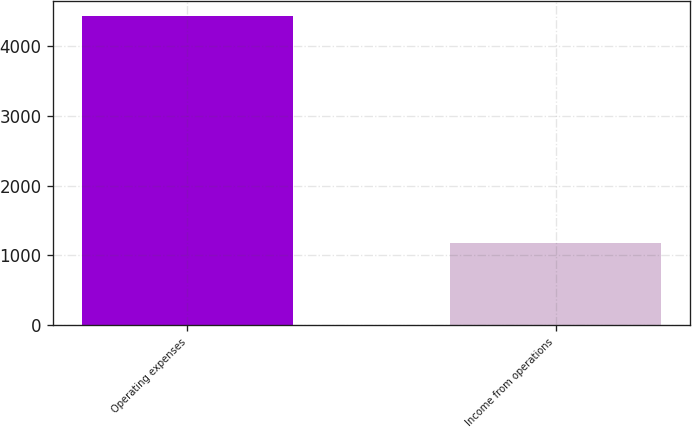Convert chart to OTSL. <chart><loc_0><loc_0><loc_500><loc_500><bar_chart><fcel>Operating expenses<fcel>Income from operations<nl><fcel>4435<fcel>1170<nl></chart> 